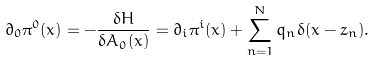Convert formula to latex. <formula><loc_0><loc_0><loc_500><loc_500>\partial _ { 0 } \pi ^ { 0 } ( x ) = - \frac { \delta H } { \delta A _ { 0 } ( x ) } = \partial _ { i } \pi ^ { i } ( x ) + \sum _ { n = 1 } ^ { N } q _ { n } \delta ( { x - z } _ { n } ) .</formula> 